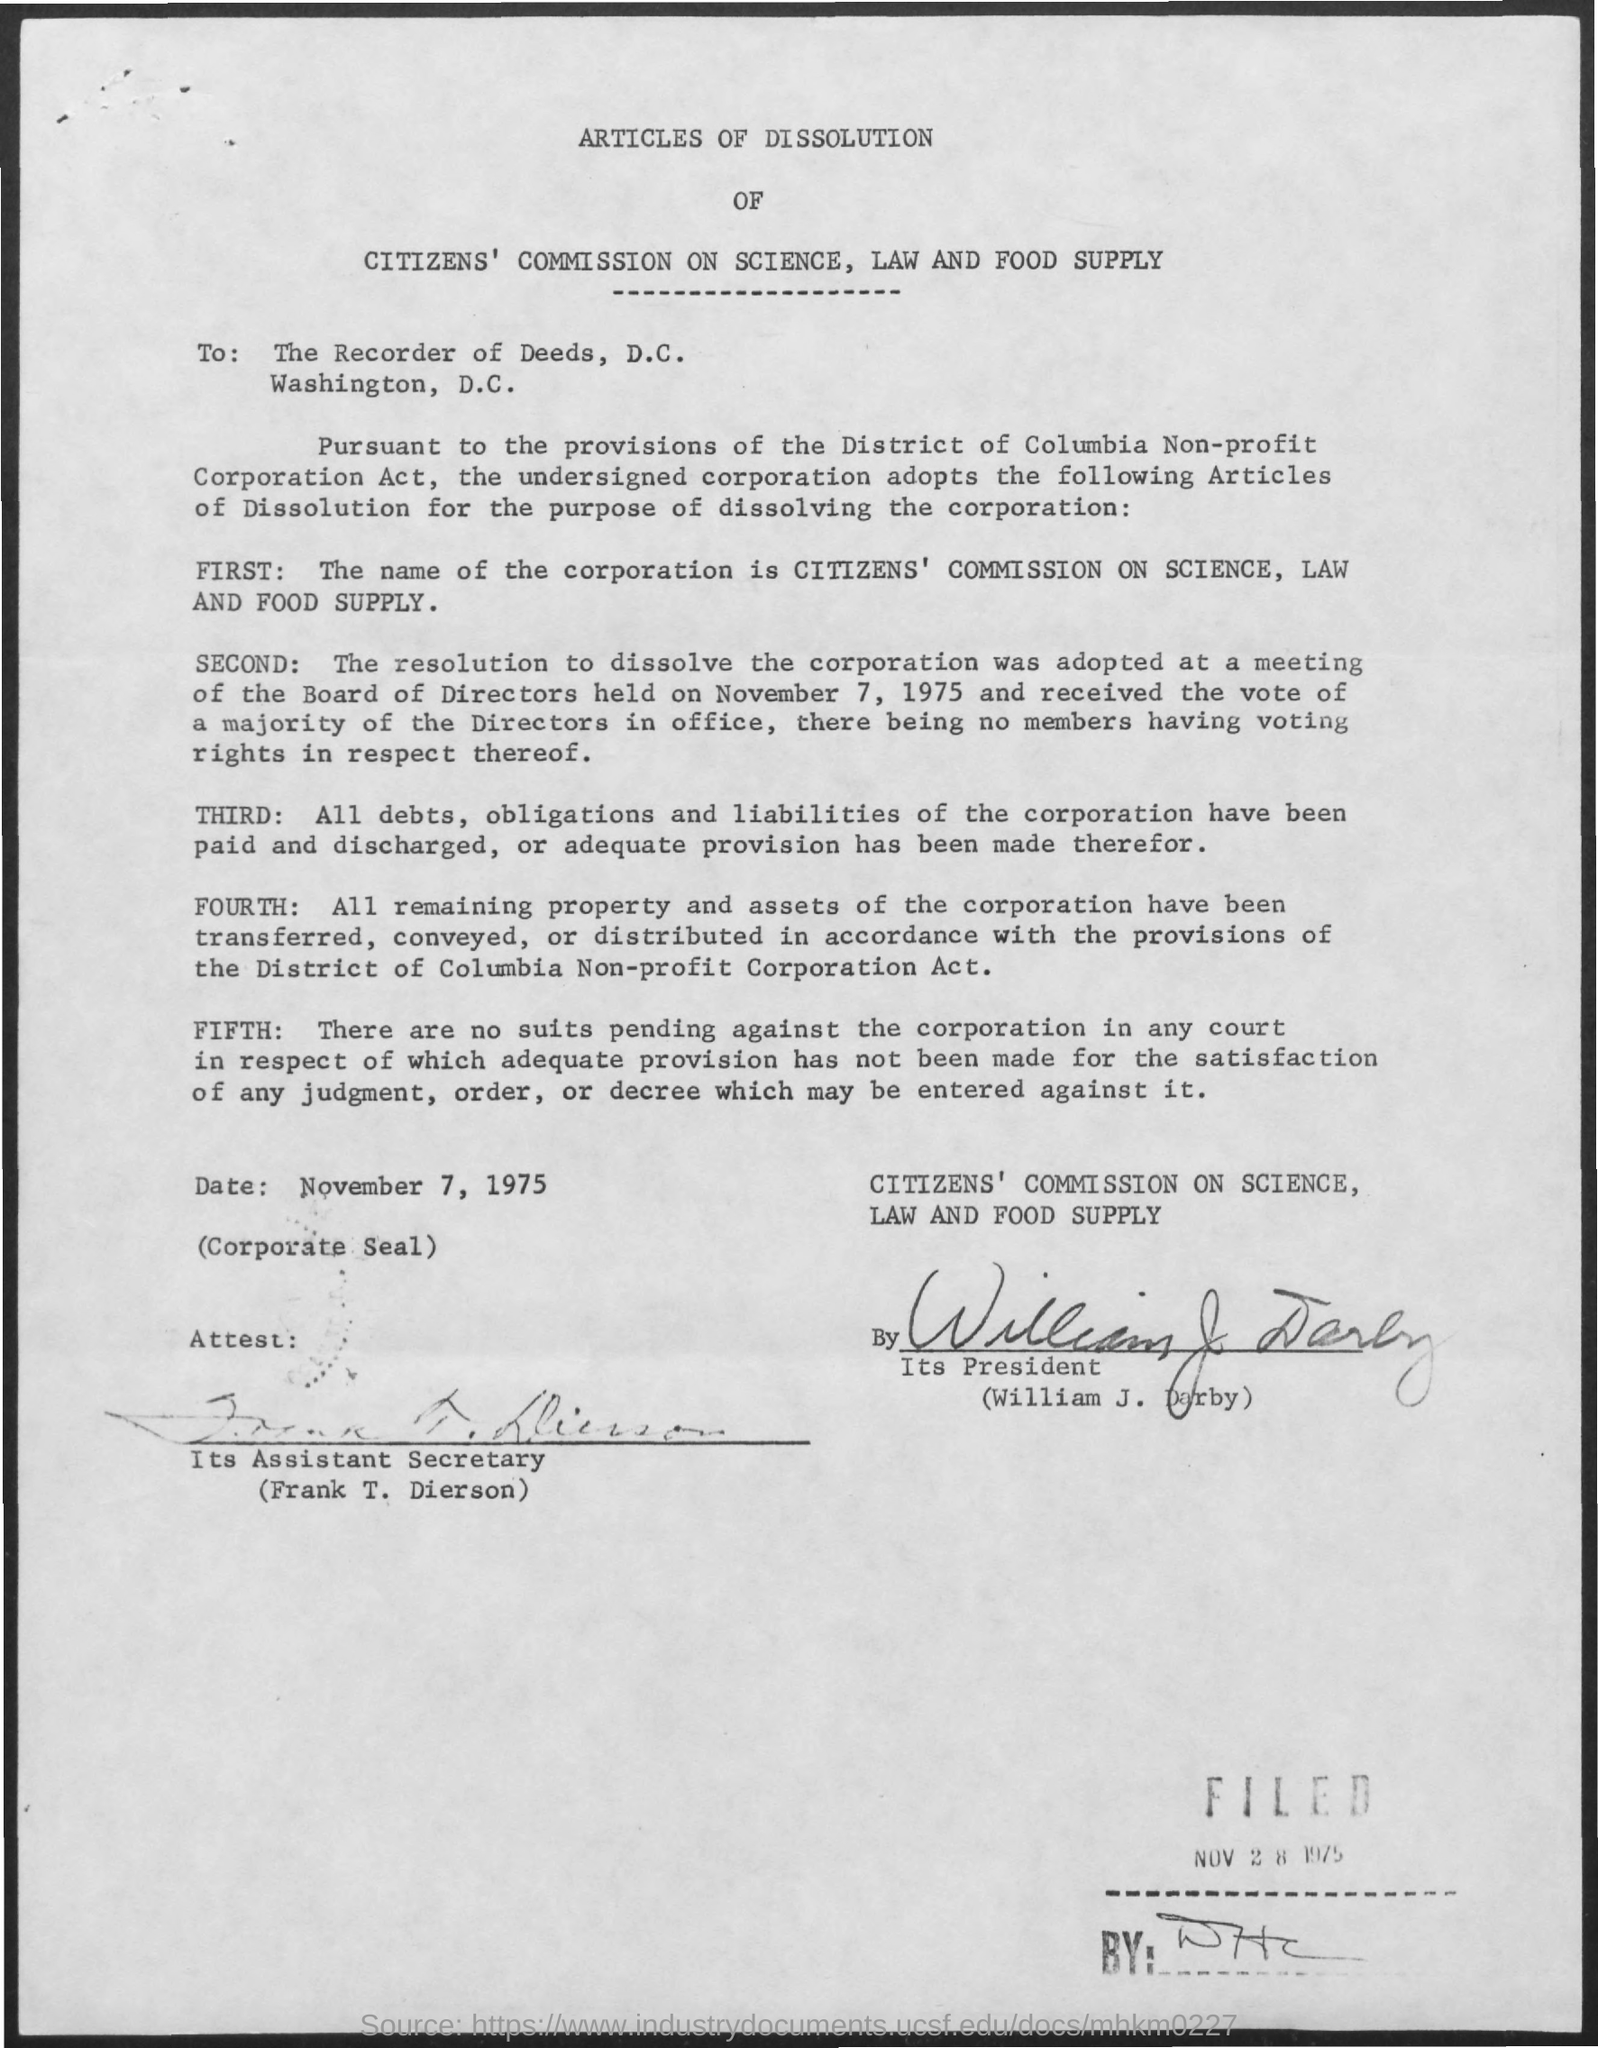Mention a couple of crucial points in this snapshot. The document has been signed by William J. Darby. The document is addressed to the Recorder of Deeds, D.C. 